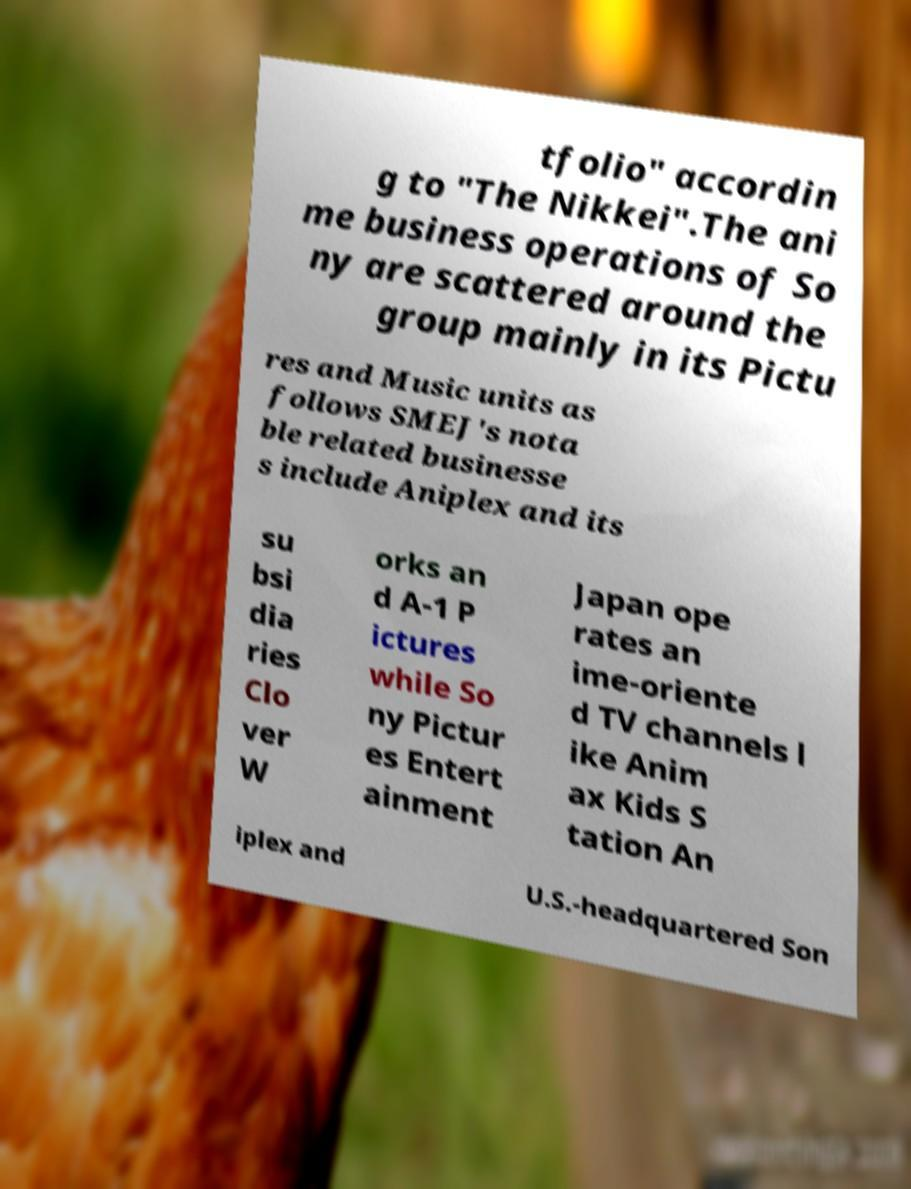Please identify and transcribe the text found in this image. tfolio" accordin g to "The Nikkei".The ani me business operations of So ny are scattered around the group mainly in its Pictu res and Music units as follows SMEJ's nota ble related businesse s include Aniplex and its su bsi dia ries Clo ver W orks an d A-1 P ictures while So ny Pictur es Entert ainment Japan ope rates an ime-oriente d TV channels l ike Anim ax Kids S tation An iplex and U.S.-headquartered Son 